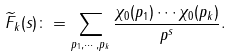<formula> <loc_0><loc_0><loc_500><loc_500>\widetilde { F } _ { k } ( s ) \colon = \sum _ { p _ { 1 } , \cdots , p _ { k } } \frac { \chi _ { 0 } ( p _ { 1 } ) \cdots \chi _ { 0 } ( p _ { k } ) } { p ^ { s } } .</formula> 